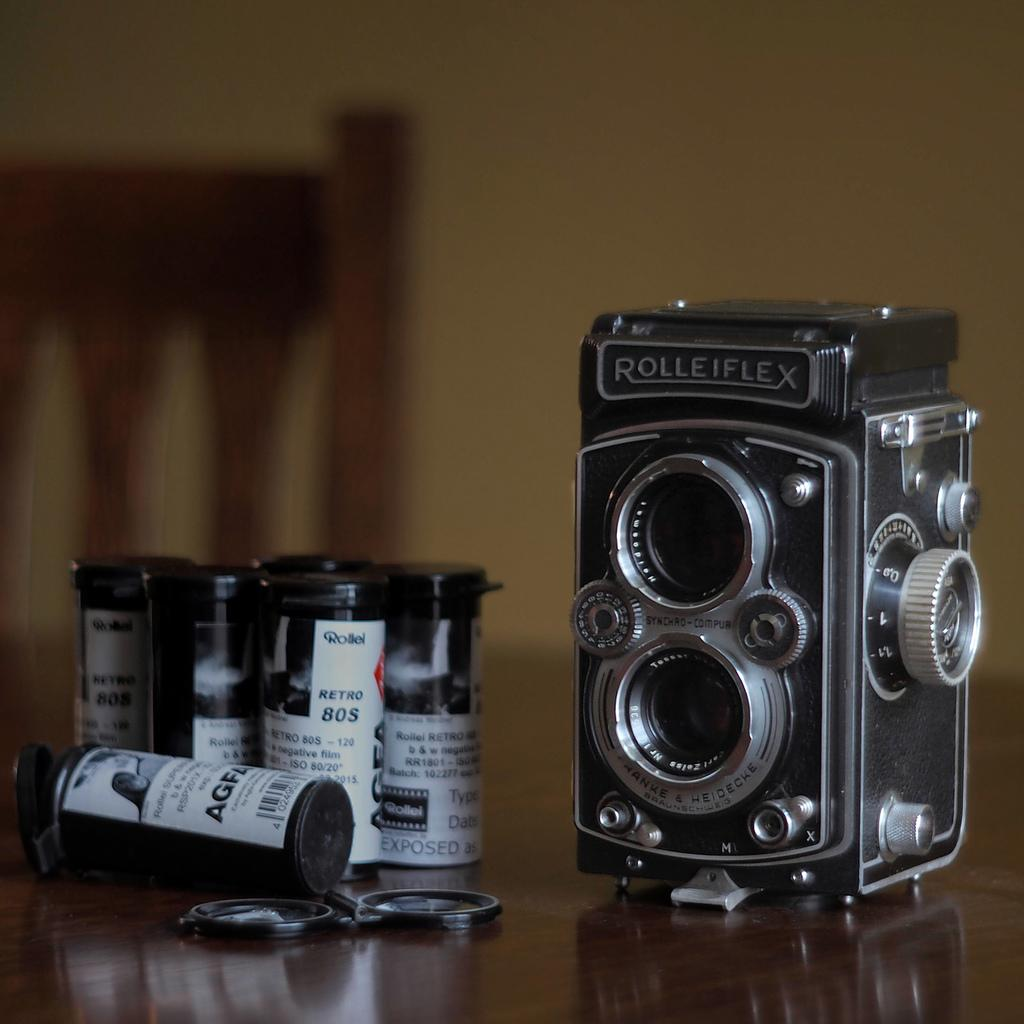What is on the wooden table in the image? There are bottles on a wooden table in the image. Are there any other objects on the wooden table besides the bottles? Yes, there are other objects on the wooden table. What can be seen in the background of the image? There is a chair and a wall in the background of the image. How is the background of the image depicted? The background of the image is blurred. What type of juice is being served by the band in the image? There is no band or juice present in the image; it only features bottles on a wooden table and a blurred background. 